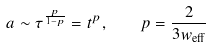Convert formula to latex. <formula><loc_0><loc_0><loc_500><loc_500>a \sim \tau ^ { \frac { p } { 1 - p } } = t ^ { p } , \quad p = \frac { 2 } { 3 w _ { \text {eff} } }</formula> 